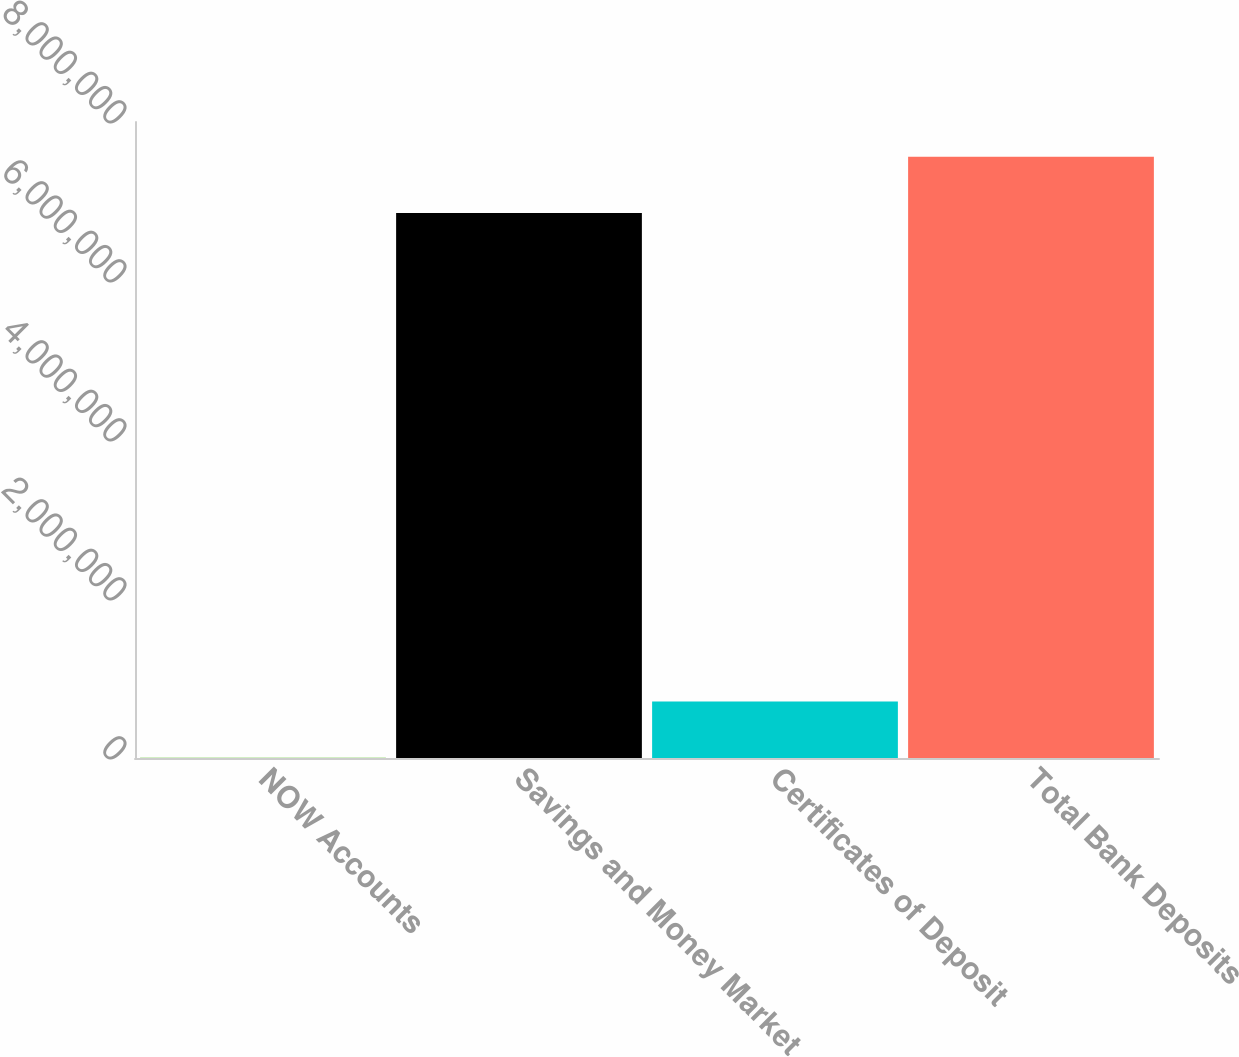Convert chart. <chart><loc_0><loc_0><loc_500><loc_500><bar_chart><fcel>NOW Accounts<fcel>Savings and Money Market<fcel>Certificates of Deposit<fcel>Total Bank Deposits<nl><fcel>3563<fcel>6.85549e+06<fcel>711178<fcel>7.56311e+06<nl></chart> 